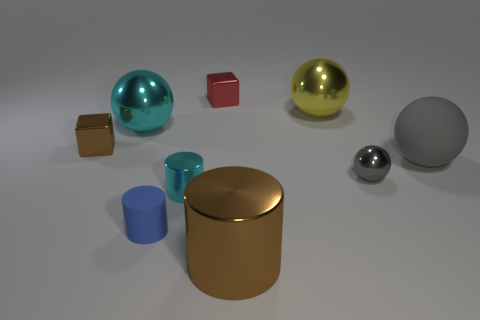Are there more small purple metallic objects than big cyan things?
Provide a succinct answer. No. What is the color of the sphere on the left side of the cyan object that is in front of the metallic block that is in front of the yellow shiny ball?
Your answer should be compact. Cyan. There is a cylinder that is in front of the small blue matte object; is its color the same as the shiny block behind the large yellow metallic sphere?
Provide a short and direct response. No. There is a shiny cylinder that is right of the tiny cyan cylinder; how many brown blocks are on the right side of it?
Offer a very short reply. 0. Is there a large brown object?
Make the answer very short. Yes. What number of other things are the same color as the small metal cylinder?
Make the answer very short. 1. Are there fewer red things than large green blocks?
Offer a very short reply. No. What shape is the brown thing that is on the left side of the brown metallic object that is right of the small cyan cylinder?
Provide a short and direct response. Cube. There is a tiny matte thing; are there any tiny gray metal things in front of it?
Your answer should be very brief. No. What is the color of the rubber object that is the same size as the cyan sphere?
Make the answer very short. Gray. 